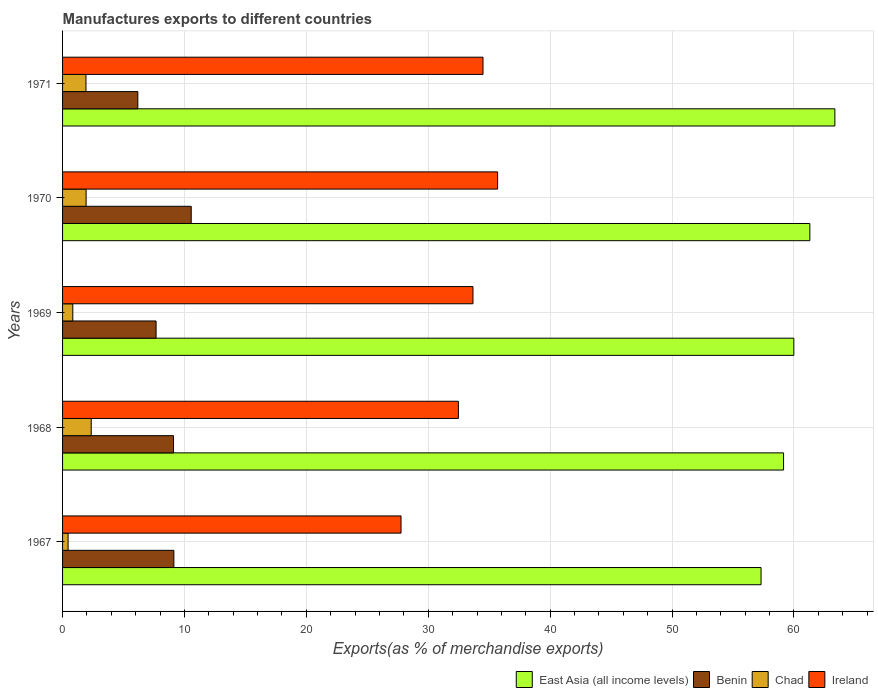How many different coloured bars are there?
Provide a succinct answer. 4. How many groups of bars are there?
Make the answer very short. 5. Are the number of bars per tick equal to the number of legend labels?
Keep it short and to the point. Yes. Are the number of bars on each tick of the Y-axis equal?
Keep it short and to the point. Yes. How many bars are there on the 4th tick from the bottom?
Your answer should be very brief. 4. What is the percentage of exports to different countries in Benin in 1967?
Provide a short and direct response. 9.13. Across all years, what is the maximum percentage of exports to different countries in Benin?
Your answer should be very brief. 10.55. Across all years, what is the minimum percentage of exports to different countries in East Asia (all income levels)?
Give a very brief answer. 57.3. In which year was the percentage of exports to different countries in Chad maximum?
Provide a short and direct response. 1968. In which year was the percentage of exports to different countries in Chad minimum?
Offer a very short reply. 1967. What is the total percentage of exports to different countries in Ireland in the graph?
Your answer should be compact. 164.08. What is the difference between the percentage of exports to different countries in Ireland in 1968 and that in 1969?
Your answer should be very brief. -1.2. What is the difference between the percentage of exports to different countries in Benin in 1967 and the percentage of exports to different countries in Chad in 1969?
Offer a terse response. 8.29. What is the average percentage of exports to different countries in Ireland per year?
Provide a short and direct response. 32.82. In the year 1971, what is the difference between the percentage of exports to different countries in Ireland and percentage of exports to different countries in East Asia (all income levels)?
Ensure brevity in your answer.  -28.87. What is the ratio of the percentage of exports to different countries in East Asia (all income levels) in 1967 to that in 1971?
Your answer should be very brief. 0.9. Is the difference between the percentage of exports to different countries in Ireland in 1970 and 1971 greater than the difference between the percentage of exports to different countries in East Asia (all income levels) in 1970 and 1971?
Your answer should be very brief. Yes. What is the difference between the highest and the second highest percentage of exports to different countries in Chad?
Make the answer very short. 0.42. What is the difference between the highest and the lowest percentage of exports to different countries in East Asia (all income levels)?
Give a very brief answer. 6.06. Is it the case that in every year, the sum of the percentage of exports to different countries in Chad and percentage of exports to different countries in Ireland is greater than the sum of percentage of exports to different countries in Benin and percentage of exports to different countries in East Asia (all income levels)?
Provide a succinct answer. No. What does the 1st bar from the top in 1971 represents?
Offer a very short reply. Ireland. What does the 4th bar from the bottom in 1967 represents?
Offer a very short reply. Ireland. Is it the case that in every year, the sum of the percentage of exports to different countries in Ireland and percentage of exports to different countries in Benin is greater than the percentage of exports to different countries in East Asia (all income levels)?
Keep it short and to the point. No. How many bars are there?
Offer a terse response. 20. Are all the bars in the graph horizontal?
Your answer should be compact. Yes. Does the graph contain any zero values?
Make the answer very short. No. How many legend labels are there?
Offer a very short reply. 4. How are the legend labels stacked?
Give a very brief answer. Horizontal. What is the title of the graph?
Your answer should be compact. Manufactures exports to different countries. Does "Kosovo" appear as one of the legend labels in the graph?
Your answer should be compact. No. What is the label or title of the X-axis?
Provide a succinct answer. Exports(as % of merchandise exports). What is the Exports(as % of merchandise exports) in East Asia (all income levels) in 1967?
Ensure brevity in your answer.  57.3. What is the Exports(as % of merchandise exports) of Benin in 1967?
Your response must be concise. 9.13. What is the Exports(as % of merchandise exports) in Chad in 1967?
Your response must be concise. 0.45. What is the Exports(as % of merchandise exports) in Ireland in 1967?
Provide a short and direct response. 27.77. What is the Exports(as % of merchandise exports) of East Asia (all income levels) in 1968?
Ensure brevity in your answer.  59.15. What is the Exports(as % of merchandise exports) in Benin in 1968?
Keep it short and to the point. 9.1. What is the Exports(as % of merchandise exports) in Chad in 1968?
Keep it short and to the point. 2.35. What is the Exports(as % of merchandise exports) in Ireland in 1968?
Offer a very short reply. 32.47. What is the Exports(as % of merchandise exports) in East Asia (all income levels) in 1969?
Make the answer very short. 59.99. What is the Exports(as % of merchandise exports) of Benin in 1969?
Give a very brief answer. 7.67. What is the Exports(as % of merchandise exports) of Chad in 1969?
Offer a very short reply. 0.84. What is the Exports(as % of merchandise exports) in Ireland in 1969?
Offer a terse response. 33.67. What is the Exports(as % of merchandise exports) of East Asia (all income levels) in 1970?
Your answer should be compact. 61.3. What is the Exports(as % of merchandise exports) of Benin in 1970?
Make the answer very short. 10.55. What is the Exports(as % of merchandise exports) in Chad in 1970?
Ensure brevity in your answer.  1.93. What is the Exports(as % of merchandise exports) of Ireland in 1970?
Provide a short and direct response. 35.69. What is the Exports(as % of merchandise exports) of East Asia (all income levels) in 1971?
Your response must be concise. 63.36. What is the Exports(as % of merchandise exports) in Benin in 1971?
Keep it short and to the point. 6.17. What is the Exports(as % of merchandise exports) of Chad in 1971?
Your answer should be very brief. 1.92. What is the Exports(as % of merchandise exports) of Ireland in 1971?
Ensure brevity in your answer.  34.49. Across all years, what is the maximum Exports(as % of merchandise exports) in East Asia (all income levels)?
Offer a terse response. 63.36. Across all years, what is the maximum Exports(as % of merchandise exports) of Benin?
Your answer should be very brief. 10.55. Across all years, what is the maximum Exports(as % of merchandise exports) in Chad?
Provide a succinct answer. 2.35. Across all years, what is the maximum Exports(as % of merchandise exports) of Ireland?
Provide a succinct answer. 35.69. Across all years, what is the minimum Exports(as % of merchandise exports) of East Asia (all income levels)?
Provide a succinct answer. 57.3. Across all years, what is the minimum Exports(as % of merchandise exports) of Benin?
Keep it short and to the point. 6.17. Across all years, what is the minimum Exports(as % of merchandise exports) in Chad?
Keep it short and to the point. 0.45. Across all years, what is the minimum Exports(as % of merchandise exports) in Ireland?
Keep it short and to the point. 27.77. What is the total Exports(as % of merchandise exports) of East Asia (all income levels) in the graph?
Ensure brevity in your answer.  301.09. What is the total Exports(as % of merchandise exports) of Benin in the graph?
Keep it short and to the point. 42.63. What is the total Exports(as % of merchandise exports) of Chad in the graph?
Your answer should be compact. 7.49. What is the total Exports(as % of merchandise exports) in Ireland in the graph?
Give a very brief answer. 164.08. What is the difference between the Exports(as % of merchandise exports) of East Asia (all income levels) in 1967 and that in 1968?
Make the answer very short. -1.85. What is the difference between the Exports(as % of merchandise exports) in Benin in 1967 and that in 1968?
Make the answer very short. 0.03. What is the difference between the Exports(as % of merchandise exports) of Chad in 1967 and that in 1968?
Offer a terse response. -1.9. What is the difference between the Exports(as % of merchandise exports) of Ireland in 1967 and that in 1968?
Offer a very short reply. -4.71. What is the difference between the Exports(as % of merchandise exports) in East Asia (all income levels) in 1967 and that in 1969?
Your answer should be compact. -2.69. What is the difference between the Exports(as % of merchandise exports) of Benin in 1967 and that in 1969?
Keep it short and to the point. 1.46. What is the difference between the Exports(as % of merchandise exports) in Chad in 1967 and that in 1969?
Your answer should be compact. -0.39. What is the difference between the Exports(as % of merchandise exports) of Ireland in 1967 and that in 1969?
Provide a short and direct response. -5.9. What is the difference between the Exports(as % of merchandise exports) of East Asia (all income levels) in 1967 and that in 1970?
Keep it short and to the point. -4. What is the difference between the Exports(as % of merchandise exports) in Benin in 1967 and that in 1970?
Offer a very short reply. -1.42. What is the difference between the Exports(as % of merchandise exports) of Chad in 1967 and that in 1970?
Ensure brevity in your answer.  -1.48. What is the difference between the Exports(as % of merchandise exports) in Ireland in 1967 and that in 1970?
Provide a succinct answer. -7.92. What is the difference between the Exports(as % of merchandise exports) in East Asia (all income levels) in 1967 and that in 1971?
Provide a succinct answer. -6.06. What is the difference between the Exports(as % of merchandise exports) of Benin in 1967 and that in 1971?
Ensure brevity in your answer.  2.96. What is the difference between the Exports(as % of merchandise exports) in Chad in 1967 and that in 1971?
Offer a terse response. -1.47. What is the difference between the Exports(as % of merchandise exports) of Ireland in 1967 and that in 1971?
Ensure brevity in your answer.  -6.72. What is the difference between the Exports(as % of merchandise exports) in East Asia (all income levels) in 1968 and that in 1969?
Ensure brevity in your answer.  -0.84. What is the difference between the Exports(as % of merchandise exports) in Benin in 1968 and that in 1969?
Provide a succinct answer. 1.43. What is the difference between the Exports(as % of merchandise exports) of Chad in 1968 and that in 1969?
Provide a succinct answer. 1.51. What is the difference between the Exports(as % of merchandise exports) of Ireland in 1968 and that in 1969?
Make the answer very short. -1.2. What is the difference between the Exports(as % of merchandise exports) in East Asia (all income levels) in 1968 and that in 1970?
Keep it short and to the point. -2.16. What is the difference between the Exports(as % of merchandise exports) in Benin in 1968 and that in 1970?
Ensure brevity in your answer.  -1.45. What is the difference between the Exports(as % of merchandise exports) in Chad in 1968 and that in 1970?
Keep it short and to the point. 0.42. What is the difference between the Exports(as % of merchandise exports) of Ireland in 1968 and that in 1970?
Offer a terse response. -3.22. What is the difference between the Exports(as % of merchandise exports) of East Asia (all income levels) in 1968 and that in 1971?
Ensure brevity in your answer.  -4.21. What is the difference between the Exports(as % of merchandise exports) of Benin in 1968 and that in 1971?
Your answer should be very brief. 2.93. What is the difference between the Exports(as % of merchandise exports) of Chad in 1968 and that in 1971?
Offer a very short reply. 0.43. What is the difference between the Exports(as % of merchandise exports) of Ireland in 1968 and that in 1971?
Offer a very short reply. -2.02. What is the difference between the Exports(as % of merchandise exports) in East Asia (all income levels) in 1969 and that in 1970?
Your answer should be compact. -1.31. What is the difference between the Exports(as % of merchandise exports) in Benin in 1969 and that in 1970?
Provide a short and direct response. -2.88. What is the difference between the Exports(as % of merchandise exports) of Chad in 1969 and that in 1970?
Your response must be concise. -1.09. What is the difference between the Exports(as % of merchandise exports) in Ireland in 1969 and that in 1970?
Provide a short and direct response. -2.02. What is the difference between the Exports(as % of merchandise exports) in East Asia (all income levels) in 1969 and that in 1971?
Provide a short and direct response. -3.37. What is the difference between the Exports(as % of merchandise exports) in Benin in 1969 and that in 1971?
Offer a very short reply. 1.5. What is the difference between the Exports(as % of merchandise exports) in Chad in 1969 and that in 1971?
Your answer should be compact. -1.08. What is the difference between the Exports(as % of merchandise exports) of Ireland in 1969 and that in 1971?
Your answer should be compact. -0.82. What is the difference between the Exports(as % of merchandise exports) in East Asia (all income levels) in 1970 and that in 1971?
Offer a very short reply. -2.05. What is the difference between the Exports(as % of merchandise exports) of Benin in 1970 and that in 1971?
Ensure brevity in your answer.  4.38. What is the difference between the Exports(as % of merchandise exports) in Chad in 1970 and that in 1971?
Make the answer very short. 0.01. What is the difference between the Exports(as % of merchandise exports) of Ireland in 1970 and that in 1971?
Your answer should be very brief. 1.2. What is the difference between the Exports(as % of merchandise exports) in East Asia (all income levels) in 1967 and the Exports(as % of merchandise exports) in Benin in 1968?
Keep it short and to the point. 48.2. What is the difference between the Exports(as % of merchandise exports) of East Asia (all income levels) in 1967 and the Exports(as % of merchandise exports) of Chad in 1968?
Offer a terse response. 54.95. What is the difference between the Exports(as % of merchandise exports) of East Asia (all income levels) in 1967 and the Exports(as % of merchandise exports) of Ireland in 1968?
Make the answer very short. 24.83. What is the difference between the Exports(as % of merchandise exports) of Benin in 1967 and the Exports(as % of merchandise exports) of Chad in 1968?
Your answer should be very brief. 6.78. What is the difference between the Exports(as % of merchandise exports) of Benin in 1967 and the Exports(as % of merchandise exports) of Ireland in 1968?
Give a very brief answer. -23.34. What is the difference between the Exports(as % of merchandise exports) in Chad in 1967 and the Exports(as % of merchandise exports) in Ireland in 1968?
Ensure brevity in your answer.  -32.02. What is the difference between the Exports(as % of merchandise exports) in East Asia (all income levels) in 1967 and the Exports(as % of merchandise exports) in Benin in 1969?
Keep it short and to the point. 49.63. What is the difference between the Exports(as % of merchandise exports) of East Asia (all income levels) in 1967 and the Exports(as % of merchandise exports) of Chad in 1969?
Offer a terse response. 56.46. What is the difference between the Exports(as % of merchandise exports) in East Asia (all income levels) in 1967 and the Exports(as % of merchandise exports) in Ireland in 1969?
Offer a terse response. 23.63. What is the difference between the Exports(as % of merchandise exports) in Benin in 1967 and the Exports(as % of merchandise exports) in Chad in 1969?
Offer a very short reply. 8.29. What is the difference between the Exports(as % of merchandise exports) in Benin in 1967 and the Exports(as % of merchandise exports) in Ireland in 1969?
Provide a short and direct response. -24.54. What is the difference between the Exports(as % of merchandise exports) in Chad in 1967 and the Exports(as % of merchandise exports) in Ireland in 1969?
Provide a short and direct response. -33.21. What is the difference between the Exports(as % of merchandise exports) of East Asia (all income levels) in 1967 and the Exports(as % of merchandise exports) of Benin in 1970?
Keep it short and to the point. 46.75. What is the difference between the Exports(as % of merchandise exports) in East Asia (all income levels) in 1967 and the Exports(as % of merchandise exports) in Chad in 1970?
Ensure brevity in your answer.  55.37. What is the difference between the Exports(as % of merchandise exports) in East Asia (all income levels) in 1967 and the Exports(as % of merchandise exports) in Ireland in 1970?
Provide a succinct answer. 21.61. What is the difference between the Exports(as % of merchandise exports) of Benin in 1967 and the Exports(as % of merchandise exports) of Chad in 1970?
Ensure brevity in your answer.  7.2. What is the difference between the Exports(as % of merchandise exports) of Benin in 1967 and the Exports(as % of merchandise exports) of Ireland in 1970?
Provide a succinct answer. -26.56. What is the difference between the Exports(as % of merchandise exports) in Chad in 1967 and the Exports(as % of merchandise exports) in Ireland in 1970?
Your response must be concise. -35.23. What is the difference between the Exports(as % of merchandise exports) of East Asia (all income levels) in 1967 and the Exports(as % of merchandise exports) of Benin in 1971?
Provide a short and direct response. 51.13. What is the difference between the Exports(as % of merchandise exports) in East Asia (all income levels) in 1967 and the Exports(as % of merchandise exports) in Chad in 1971?
Your response must be concise. 55.38. What is the difference between the Exports(as % of merchandise exports) in East Asia (all income levels) in 1967 and the Exports(as % of merchandise exports) in Ireland in 1971?
Provide a short and direct response. 22.81. What is the difference between the Exports(as % of merchandise exports) in Benin in 1967 and the Exports(as % of merchandise exports) in Chad in 1971?
Provide a short and direct response. 7.21. What is the difference between the Exports(as % of merchandise exports) in Benin in 1967 and the Exports(as % of merchandise exports) in Ireland in 1971?
Your answer should be compact. -25.36. What is the difference between the Exports(as % of merchandise exports) of Chad in 1967 and the Exports(as % of merchandise exports) of Ireland in 1971?
Your answer should be very brief. -34.04. What is the difference between the Exports(as % of merchandise exports) of East Asia (all income levels) in 1968 and the Exports(as % of merchandise exports) of Benin in 1969?
Ensure brevity in your answer.  51.48. What is the difference between the Exports(as % of merchandise exports) of East Asia (all income levels) in 1968 and the Exports(as % of merchandise exports) of Chad in 1969?
Offer a very short reply. 58.31. What is the difference between the Exports(as % of merchandise exports) in East Asia (all income levels) in 1968 and the Exports(as % of merchandise exports) in Ireland in 1969?
Your answer should be compact. 25.48. What is the difference between the Exports(as % of merchandise exports) of Benin in 1968 and the Exports(as % of merchandise exports) of Chad in 1969?
Your answer should be very brief. 8.26. What is the difference between the Exports(as % of merchandise exports) in Benin in 1968 and the Exports(as % of merchandise exports) in Ireland in 1969?
Keep it short and to the point. -24.57. What is the difference between the Exports(as % of merchandise exports) in Chad in 1968 and the Exports(as % of merchandise exports) in Ireland in 1969?
Your answer should be very brief. -31.32. What is the difference between the Exports(as % of merchandise exports) in East Asia (all income levels) in 1968 and the Exports(as % of merchandise exports) in Benin in 1970?
Give a very brief answer. 48.59. What is the difference between the Exports(as % of merchandise exports) of East Asia (all income levels) in 1968 and the Exports(as % of merchandise exports) of Chad in 1970?
Give a very brief answer. 57.22. What is the difference between the Exports(as % of merchandise exports) of East Asia (all income levels) in 1968 and the Exports(as % of merchandise exports) of Ireland in 1970?
Keep it short and to the point. 23.46. What is the difference between the Exports(as % of merchandise exports) of Benin in 1968 and the Exports(as % of merchandise exports) of Chad in 1970?
Your answer should be compact. 7.17. What is the difference between the Exports(as % of merchandise exports) of Benin in 1968 and the Exports(as % of merchandise exports) of Ireland in 1970?
Give a very brief answer. -26.59. What is the difference between the Exports(as % of merchandise exports) of Chad in 1968 and the Exports(as % of merchandise exports) of Ireland in 1970?
Make the answer very short. -33.34. What is the difference between the Exports(as % of merchandise exports) of East Asia (all income levels) in 1968 and the Exports(as % of merchandise exports) of Benin in 1971?
Your response must be concise. 52.97. What is the difference between the Exports(as % of merchandise exports) of East Asia (all income levels) in 1968 and the Exports(as % of merchandise exports) of Chad in 1971?
Give a very brief answer. 57.23. What is the difference between the Exports(as % of merchandise exports) of East Asia (all income levels) in 1968 and the Exports(as % of merchandise exports) of Ireland in 1971?
Provide a succinct answer. 24.66. What is the difference between the Exports(as % of merchandise exports) in Benin in 1968 and the Exports(as % of merchandise exports) in Chad in 1971?
Make the answer very short. 7.18. What is the difference between the Exports(as % of merchandise exports) in Benin in 1968 and the Exports(as % of merchandise exports) in Ireland in 1971?
Your answer should be compact. -25.39. What is the difference between the Exports(as % of merchandise exports) of Chad in 1968 and the Exports(as % of merchandise exports) of Ireland in 1971?
Your answer should be very brief. -32.14. What is the difference between the Exports(as % of merchandise exports) of East Asia (all income levels) in 1969 and the Exports(as % of merchandise exports) of Benin in 1970?
Make the answer very short. 49.43. What is the difference between the Exports(as % of merchandise exports) in East Asia (all income levels) in 1969 and the Exports(as % of merchandise exports) in Chad in 1970?
Your answer should be compact. 58.06. What is the difference between the Exports(as % of merchandise exports) in East Asia (all income levels) in 1969 and the Exports(as % of merchandise exports) in Ireland in 1970?
Keep it short and to the point. 24.3. What is the difference between the Exports(as % of merchandise exports) in Benin in 1969 and the Exports(as % of merchandise exports) in Chad in 1970?
Provide a succinct answer. 5.74. What is the difference between the Exports(as % of merchandise exports) in Benin in 1969 and the Exports(as % of merchandise exports) in Ireland in 1970?
Offer a very short reply. -28.02. What is the difference between the Exports(as % of merchandise exports) of Chad in 1969 and the Exports(as % of merchandise exports) of Ireland in 1970?
Your answer should be compact. -34.85. What is the difference between the Exports(as % of merchandise exports) in East Asia (all income levels) in 1969 and the Exports(as % of merchandise exports) in Benin in 1971?
Provide a succinct answer. 53.81. What is the difference between the Exports(as % of merchandise exports) of East Asia (all income levels) in 1969 and the Exports(as % of merchandise exports) of Chad in 1971?
Offer a terse response. 58.07. What is the difference between the Exports(as % of merchandise exports) of East Asia (all income levels) in 1969 and the Exports(as % of merchandise exports) of Ireland in 1971?
Ensure brevity in your answer.  25.5. What is the difference between the Exports(as % of merchandise exports) in Benin in 1969 and the Exports(as % of merchandise exports) in Chad in 1971?
Make the answer very short. 5.75. What is the difference between the Exports(as % of merchandise exports) in Benin in 1969 and the Exports(as % of merchandise exports) in Ireland in 1971?
Provide a short and direct response. -26.82. What is the difference between the Exports(as % of merchandise exports) of Chad in 1969 and the Exports(as % of merchandise exports) of Ireland in 1971?
Give a very brief answer. -33.65. What is the difference between the Exports(as % of merchandise exports) in East Asia (all income levels) in 1970 and the Exports(as % of merchandise exports) in Benin in 1971?
Offer a very short reply. 55.13. What is the difference between the Exports(as % of merchandise exports) in East Asia (all income levels) in 1970 and the Exports(as % of merchandise exports) in Chad in 1971?
Offer a very short reply. 59.38. What is the difference between the Exports(as % of merchandise exports) of East Asia (all income levels) in 1970 and the Exports(as % of merchandise exports) of Ireland in 1971?
Ensure brevity in your answer.  26.81. What is the difference between the Exports(as % of merchandise exports) in Benin in 1970 and the Exports(as % of merchandise exports) in Chad in 1971?
Give a very brief answer. 8.63. What is the difference between the Exports(as % of merchandise exports) of Benin in 1970 and the Exports(as % of merchandise exports) of Ireland in 1971?
Provide a short and direct response. -23.94. What is the difference between the Exports(as % of merchandise exports) in Chad in 1970 and the Exports(as % of merchandise exports) in Ireland in 1971?
Give a very brief answer. -32.56. What is the average Exports(as % of merchandise exports) of East Asia (all income levels) per year?
Offer a terse response. 60.22. What is the average Exports(as % of merchandise exports) in Benin per year?
Keep it short and to the point. 8.53. What is the average Exports(as % of merchandise exports) of Chad per year?
Offer a very short reply. 1.5. What is the average Exports(as % of merchandise exports) of Ireland per year?
Your answer should be compact. 32.82. In the year 1967, what is the difference between the Exports(as % of merchandise exports) of East Asia (all income levels) and Exports(as % of merchandise exports) of Benin?
Your answer should be very brief. 48.17. In the year 1967, what is the difference between the Exports(as % of merchandise exports) in East Asia (all income levels) and Exports(as % of merchandise exports) in Chad?
Your answer should be very brief. 56.85. In the year 1967, what is the difference between the Exports(as % of merchandise exports) in East Asia (all income levels) and Exports(as % of merchandise exports) in Ireland?
Ensure brevity in your answer.  29.53. In the year 1967, what is the difference between the Exports(as % of merchandise exports) in Benin and Exports(as % of merchandise exports) in Chad?
Your answer should be very brief. 8.68. In the year 1967, what is the difference between the Exports(as % of merchandise exports) in Benin and Exports(as % of merchandise exports) in Ireland?
Ensure brevity in your answer.  -18.64. In the year 1967, what is the difference between the Exports(as % of merchandise exports) of Chad and Exports(as % of merchandise exports) of Ireland?
Your answer should be compact. -27.31. In the year 1968, what is the difference between the Exports(as % of merchandise exports) of East Asia (all income levels) and Exports(as % of merchandise exports) of Benin?
Your answer should be very brief. 50.05. In the year 1968, what is the difference between the Exports(as % of merchandise exports) of East Asia (all income levels) and Exports(as % of merchandise exports) of Chad?
Provide a short and direct response. 56.8. In the year 1968, what is the difference between the Exports(as % of merchandise exports) in East Asia (all income levels) and Exports(as % of merchandise exports) in Ireland?
Keep it short and to the point. 26.68. In the year 1968, what is the difference between the Exports(as % of merchandise exports) in Benin and Exports(as % of merchandise exports) in Chad?
Offer a terse response. 6.75. In the year 1968, what is the difference between the Exports(as % of merchandise exports) of Benin and Exports(as % of merchandise exports) of Ireland?
Make the answer very short. -23.37. In the year 1968, what is the difference between the Exports(as % of merchandise exports) in Chad and Exports(as % of merchandise exports) in Ireland?
Give a very brief answer. -30.12. In the year 1969, what is the difference between the Exports(as % of merchandise exports) of East Asia (all income levels) and Exports(as % of merchandise exports) of Benin?
Provide a short and direct response. 52.32. In the year 1969, what is the difference between the Exports(as % of merchandise exports) of East Asia (all income levels) and Exports(as % of merchandise exports) of Chad?
Your response must be concise. 59.15. In the year 1969, what is the difference between the Exports(as % of merchandise exports) of East Asia (all income levels) and Exports(as % of merchandise exports) of Ireland?
Your answer should be compact. 26.32. In the year 1969, what is the difference between the Exports(as % of merchandise exports) in Benin and Exports(as % of merchandise exports) in Chad?
Your answer should be very brief. 6.83. In the year 1969, what is the difference between the Exports(as % of merchandise exports) in Benin and Exports(as % of merchandise exports) in Ireland?
Ensure brevity in your answer.  -26. In the year 1969, what is the difference between the Exports(as % of merchandise exports) in Chad and Exports(as % of merchandise exports) in Ireland?
Offer a terse response. -32.83. In the year 1970, what is the difference between the Exports(as % of merchandise exports) of East Asia (all income levels) and Exports(as % of merchandise exports) of Benin?
Your answer should be compact. 50.75. In the year 1970, what is the difference between the Exports(as % of merchandise exports) in East Asia (all income levels) and Exports(as % of merchandise exports) in Chad?
Your answer should be very brief. 59.37. In the year 1970, what is the difference between the Exports(as % of merchandise exports) in East Asia (all income levels) and Exports(as % of merchandise exports) in Ireland?
Your response must be concise. 25.61. In the year 1970, what is the difference between the Exports(as % of merchandise exports) in Benin and Exports(as % of merchandise exports) in Chad?
Offer a very short reply. 8.62. In the year 1970, what is the difference between the Exports(as % of merchandise exports) of Benin and Exports(as % of merchandise exports) of Ireland?
Ensure brevity in your answer.  -25.13. In the year 1970, what is the difference between the Exports(as % of merchandise exports) in Chad and Exports(as % of merchandise exports) in Ireland?
Give a very brief answer. -33.76. In the year 1971, what is the difference between the Exports(as % of merchandise exports) in East Asia (all income levels) and Exports(as % of merchandise exports) in Benin?
Keep it short and to the point. 57.18. In the year 1971, what is the difference between the Exports(as % of merchandise exports) in East Asia (all income levels) and Exports(as % of merchandise exports) in Chad?
Offer a terse response. 61.44. In the year 1971, what is the difference between the Exports(as % of merchandise exports) in East Asia (all income levels) and Exports(as % of merchandise exports) in Ireland?
Your response must be concise. 28.87. In the year 1971, what is the difference between the Exports(as % of merchandise exports) in Benin and Exports(as % of merchandise exports) in Chad?
Offer a very short reply. 4.26. In the year 1971, what is the difference between the Exports(as % of merchandise exports) in Benin and Exports(as % of merchandise exports) in Ireland?
Provide a short and direct response. -28.32. In the year 1971, what is the difference between the Exports(as % of merchandise exports) in Chad and Exports(as % of merchandise exports) in Ireland?
Offer a terse response. -32.57. What is the ratio of the Exports(as % of merchandise exports) of East Asia (all income levels) in 1967 to that in 1968?
Keep it short and to the point. 0.97. What is the ratio of the Exports(as % of merchandise exports) of Benin in 1967 to that in 1968?
Give a very brief answer. 1. What is the ratio of the Exports(as % of merchandise exports) in Chad in 1967 to that in 1968?
Your answer should be very brief. 0.19. What is the ratio of the Exports(as % of merchandise exports) of Ireland in 1967 to that in 1968?
Give a very brief answer. 0.86. What is the ratio of the Exports(as % of merchandise exports) of East Asia (all income levels) in 1967 to that in 1969?
Your response must be concise. 0.96. What is the ratio of the Exports(as % of merchandise exports) of Benin in 1967 to that in 1969?
Keep it short and to the point. 1.19. What is the ratio of the Exports(as % of merchandise exports) of Chad in 1967 to that in 1969?
Your answer should be compact. 0.54. What is the ratio of the Exports(as % of merchandise exports) of Ireland in 1967 to that in 1969?
Your response must be concise. 0.82. What is the ratio of the Exports(as % of merchandise exports) in East Asia (all income levels) in 1967 to that in 1970?
Your answer should be very brief. 0.93. What is the ratio of the Exports(as % of merchandise exports) in Benin in 1967 to that in 1970?
Ensure brevity in your answer.  0.87. What is the ratio of the Exports(as % of merchandise exports) in Chad in 1967 to that in 1970?
Provide a succinct answer. 0.23. What is the ratio of the Exports(as % of merchandise exports) of Ireland in 1967 to that in 1970?
Make the answer very short. 0.78. What is the ratio of the Exports(as % of merchandise exports) of East Asia (all income levels) in 1967 to that in 1971?
Offer a terse response. 0.9. What is the ratio of the Exports(as % of merchandise exports) in Benin in 1967 to that in 1971?
Ensure brevity in your answer.  1.48. What is the ratio of the Exports(as % of merchandise exports) of Chad in 1967 to that in 1971?
Provide a short and direct response. 0.24. What is the ratio of the Exports(as % of merchandise exports) in Ireland in 1967 to that in 1971?
Ensure brevity in your answer.  0.81. What is the ratio of the Exports(as % of merchandise exports) in East Asia (all income levels) in 1968 to that in 1969?
Provide a short and direct response. 0.99. What is the ratio of the Exports(as % of merchandise exports) of Benin in 1968 to that in 1969?
Offer a very short reply. 1.19. What is the ratio of the Exports(as % of merchandise exports) of Chad in 1968 to that in 1969?
Your response must be concise. 2.8. What is the ratio of the Exports(as % of merchandise exports) of Ireland in 1968 to that in 1969?
Ensure brevity in your answer.  0.96. What is the ratio of the Exports(as % of merchandise exports) of East Asia (all income levels) in 1968 to that in 1970?
Your answer should be compact. 0.96. What is the ratio of the Exports(as % of merchandise exports) in Benin in 1968 to that in 1970?
Your answer should be compact. 0.86. What is the ratio of the Exports(as % of merchandise exports) of Chad in 1968 to that in 1970?
Ensure brevity in your answer.  1.22. What is the ratio of the Exports(as % of merchandise exports) of Ireland in 1968 to that in 1970?
Your answer should be very brief. 0.91. What is the ratio of the Exports(as % of merchandise exports) in East Asia (all income levels) in 1968 to that in 1971?
Your answer should be very brief. 0.93. What is the ratio of the Exports(as % of merchandise exports) in Benin in 1968 to that in 1971?
Keep it short and to the point. 1.47. What is the ratio of the Exports(as % of merchandise exports) in Chad in 1968 to that in 1971?
Your answer should be very brief. 1.22. What is the ratio of the Exports(as % of merchandise exports) of Ireland in 1968 to that in 1971?
Keep it short and to the point. 0.94. What is the ratio of the Exports(as % of merchandise exports) of East Asia (all income levels) in 1969 to that in 1970?
Provide a short and direct response. 0.98. What is the ratio of the Exports(as % of merchandise exports) in Benin in 1969 to that in 1970?
Offer a very short reply. 0.73. What is the ratio of the Exports(as % of merchandise exports) of Chad in 1969 to that in 1970?
Offer a very short reply. 0.43. What is the ratio of the Exports(as % of merchandise exports) of Ireland in 1969 to that in 1970?
Make the answer very short. 0.94. What is the ratio of the Exports(as % of merchandise exports) of East Asia (all income levels) in 1969 to that in 1971?
Keep it short and to the point. 0.95. What is the ratio of the Exports(as % of merchandise exports) in Benin in 1969 to that in 1971?
Your answer should be very brief. 1.24. What is the ratio of the Exports(as % of merchandise exports) in Chad in 1969 to that in 1971?
Ensure brevity in your answer.  0.44. What is the ratio of the Exports(as % of merchandise exports) of Ireland in 1969 to that in 1971?
Your response must be concise. 0.98. What is the ratio of the Exports(as % of merchandise exports) in East Asia (all income levels) in 1970 to that in 1971?
Provide a short and direct response. 0.97. What is the ratio of the Exports(as % of merchandise exports) in Benin in 1970 to that in 1971?
Provide a succinct answer. 1.71. What is the ratio of the Exports(as % of merchandise exports) in Ireland in 1970 to that in 1971?
Your answer should be very brief. 1.03. What is the difference between the highest and the second highest Exports(as % of merchandise exports) in East Asia (all income levels)?
Keep it short and to the point. 2.05. What is the difference between the highest and the second highest Exports(as % of merchandise exports) in Benin?
Make the answer very short. 1.42. What is the difference between the highest and the second highest Exports(as % of merchandise exports) in Chad?
Keep it short and to the point. 0.42. What is the difference between the highest and the second highest Exports(as % of merchandise exports) in Ireland?
Keep it short and to the point. 1.2. What is the difference between the highest and the lowest Exports(as % of merchandise exports) of East Asia (all income levels)?
Offer a terse response. 6.06. What is the difference between the highest and the lowest Exports(as % of merchandise exports) in Benin?
Your answer should be very brief. 4.38. What is the difference between the highest and the lowest Exports(as % of merchandise exports) in Chad?
Provide a succinct answer. 1.9. What is the difference between the highest and the lowest Exports(as % of merchandise exports) in Ireland?
Give a very brief answer. 7.92. 